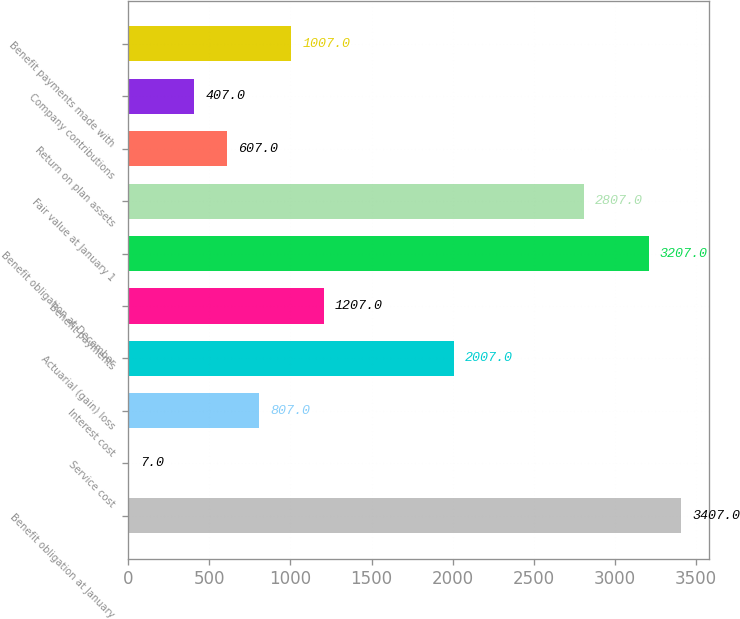<chart> <loc_0><loc_0><loc_500><loc_500><bar_chart><fcel>Benefit obligation at January<fcel>Service cost<fcel>Interest cost<fcel>Actuarial (gain) loss<fcel>Benefit payments<fcel>Benefit obligation at December<fcel>Fair value at January 1<fcel>Return on plan assets<fcel>Company contributions<fcel>Benefit payments made with<nl><fcel>3407<fcel>7<fcel>807<fcel>2007<fcel>1207<fcel>3207<fcel>2807<fcel>607<fcel>407<fcel>1007<nl></chart> 